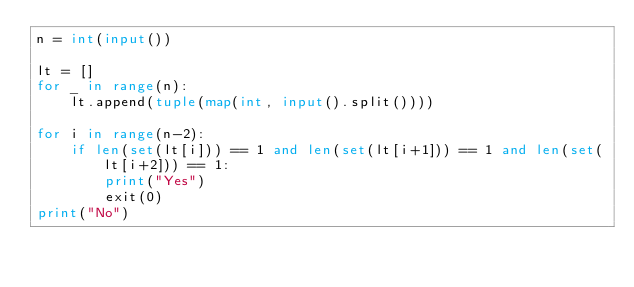<code> <loc_0><loc_0><loc_500><loc_500><_Python_>n = int(input())

lt = []
for _ in range(n):
    lt.append(tuple(map(int, input().split())))

for i in range(n-2):
    if len(set(lt[i])) == 1 and len(set(lt[i+1])) == 1 and len(set(lt[i+2])) == 1:
        print("Yes")
        exit(0)
print("No")
</code> 